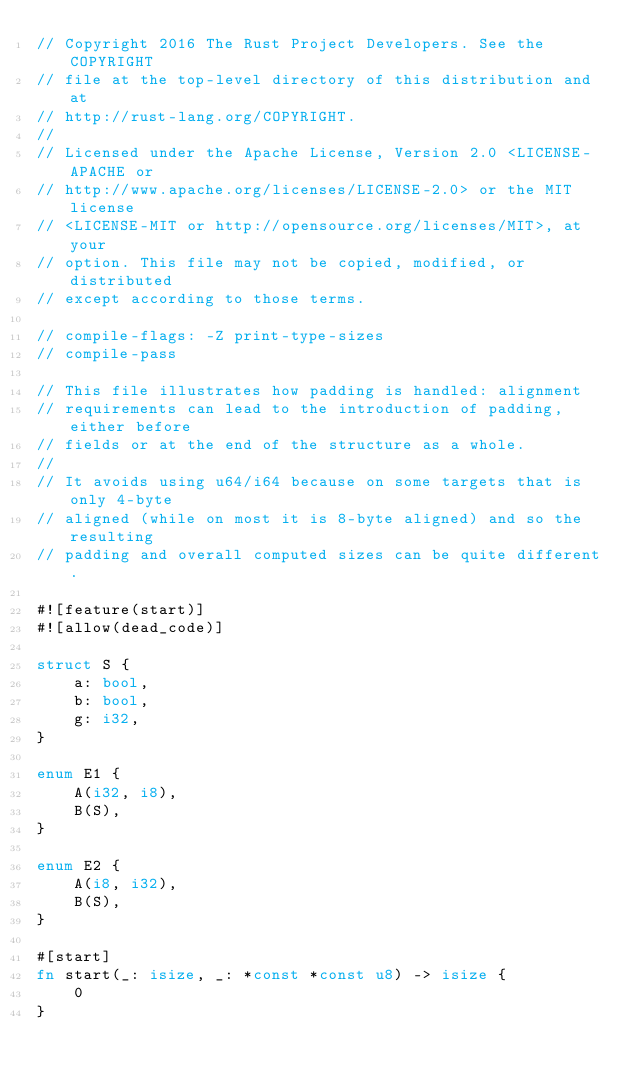Convert code to text. <code><loc_0><loc_0><loc_500><loc_500><_Rust_>// Copyright 2016 The Rust Project Developers. See the COPYRIGHT
// file at the top-level directory of this distribution and at
// http://rust-lang.org/COPYRIGHT.
//
// Licensed under the Apache License, Version 2.0 <LICENSE-APACHE or
// http://www.apache.org/licenses/LICENSE-2.0> or the MIT license
// <LICENSE-MIT or http://opensource.org/licenses/MIT>, at your
// option. This file may not be copied, modified, or distributed
// except according to those terms.

// compile-flags: -Z print-type-sizes
// compile-pass

// This file illustrates how padding is handled: alignment
// requirements can lead to the introduction of padding, either before
// fields or at the end of the structure as a whole.
//
// It avoids using u64/i64 because on some targets that is only 4-byte
// aligned (while on most it is 8-byte aligned) and so the resulting
// padding and overall computed sizes can be quite different.

#![feature(start)]
#![allow(dead_code)]

struct S {
    a: bool,
    b: bool,
    g: i32,
}

enum E1 {
    A(i32, i8),
    B(S),
}

enum E2 {
    A(i8, i32),
    B(S),
}

#[start]
fn start(_: isize, _: *const *const u8) -> isize {
    0
}
</code> 